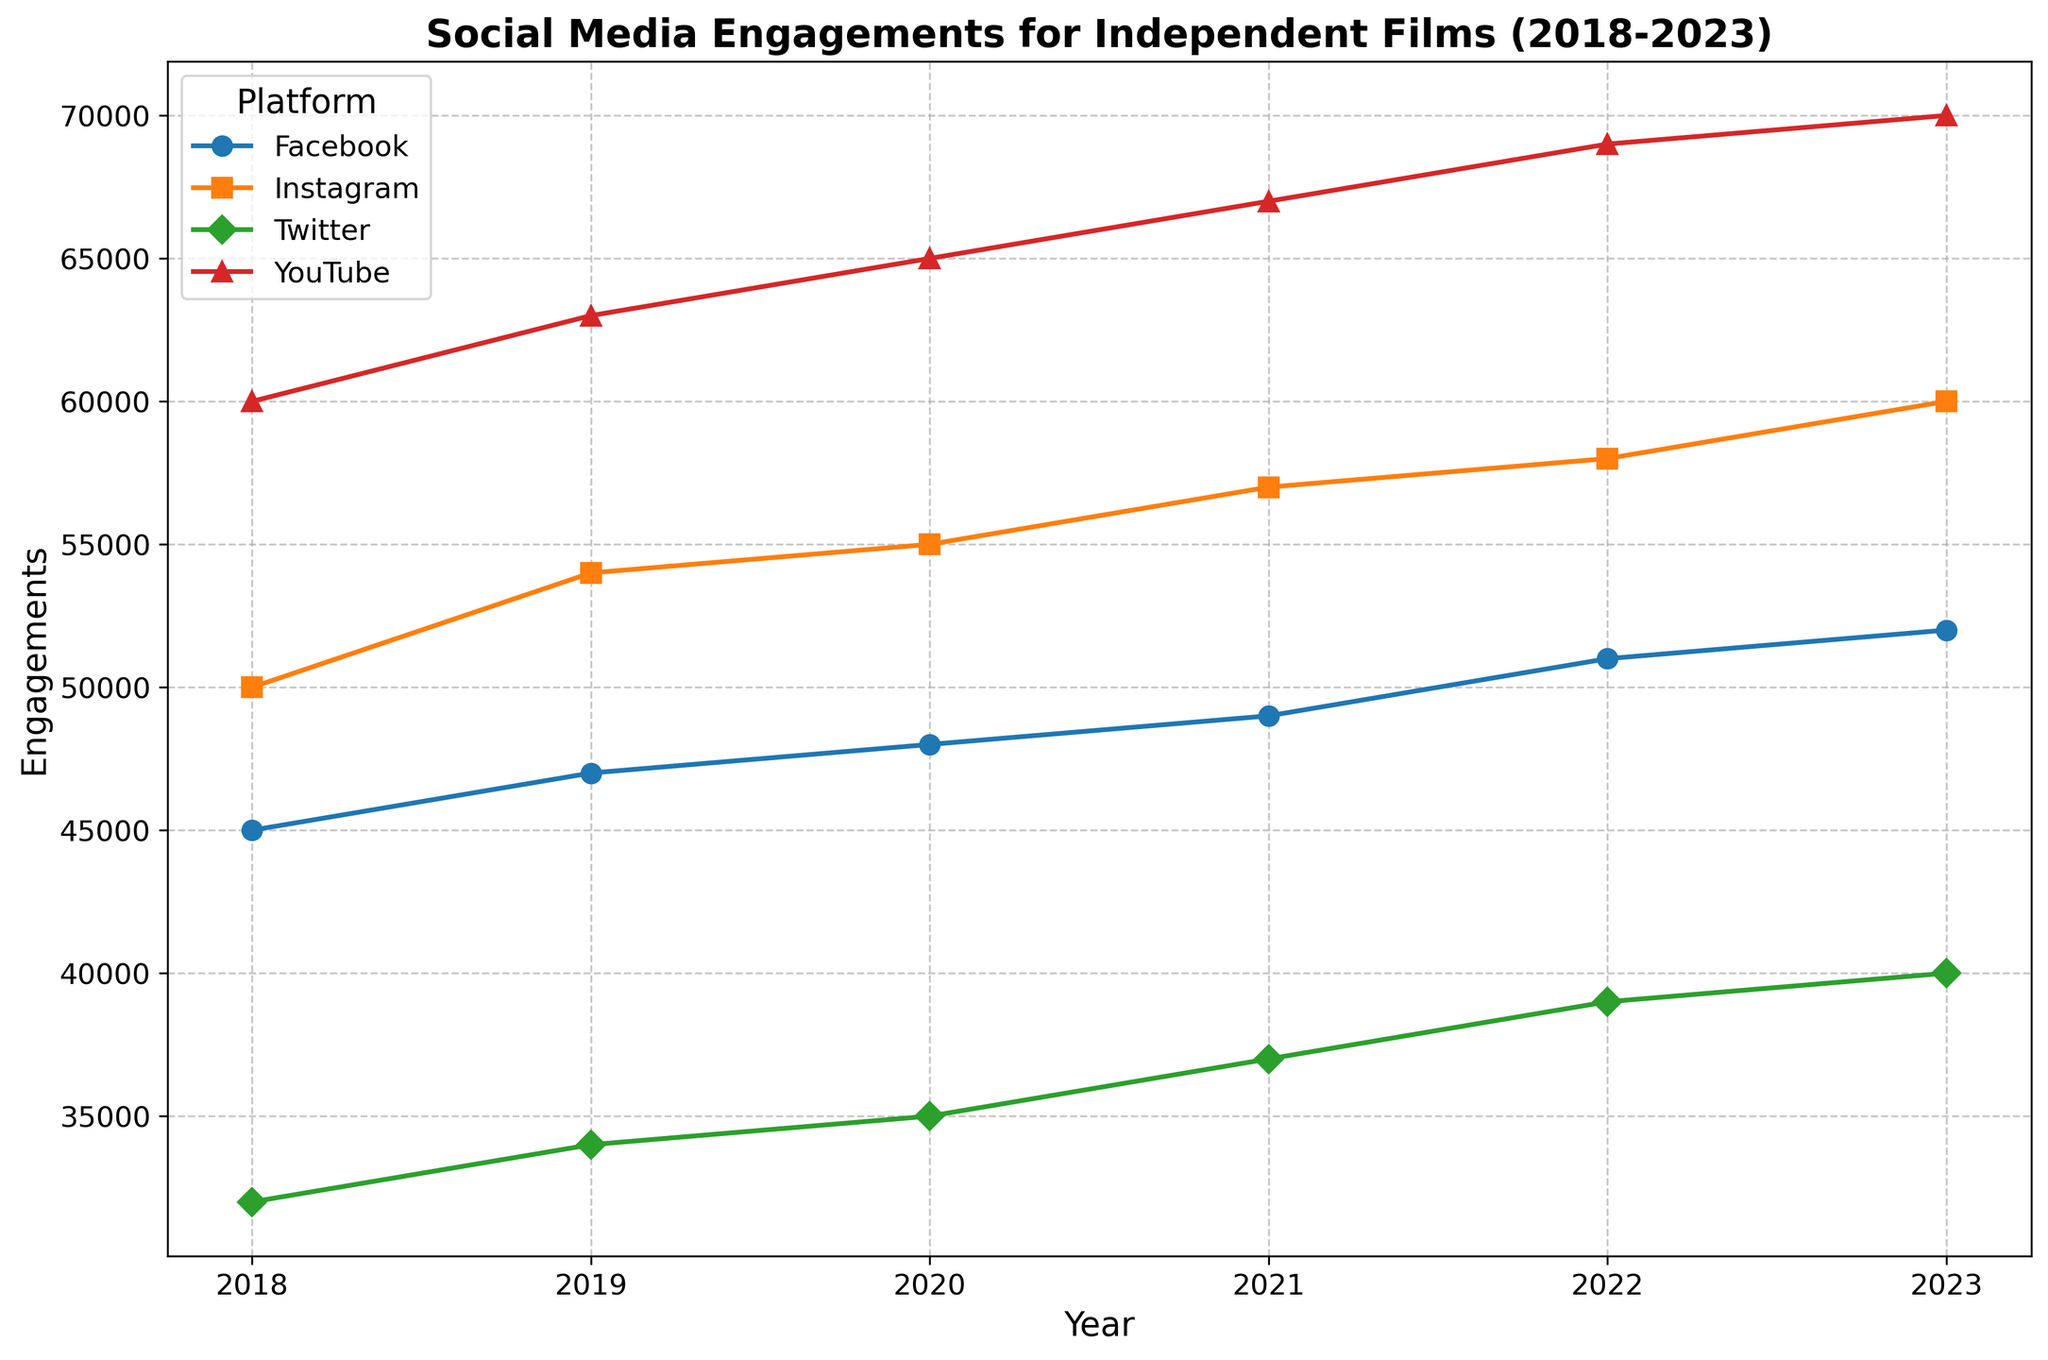How did Instagram engagements change from 2018 to 2023? Look at the Instagram line in the chart. Compare the engagement value in 2018 with the value in 2023. Engagements in 2018 were 50,000, and in 2023 they reached 60,000.
Answer: Increased by 10,000 Which platform saw the highest engagement in 2023? Refer to the final year (2023) on the x-axis and identify the platform with the highest engagement value. YouTube has the highest engagement with 70,000.
Answer: YouTube Did any platform's engagements decrease from 2018 to 2023? Observe the trend of each platform from 2018 to 2023. None of the platforms show a decreasing trend over the years.
Answer: No Between 2019 and 2020, which platform had the largest increase in engagements? Compare the engagement values for each platform between 2019 and 2020. Calculate the differences: 
- Facebook: 48,000 - 47,000 = 1,000
- Twitter: 35,000 - 34,000 = 1,000
- Instagram: 55,000 - 54,000 = 1,000
- YouTube: 65,000 - 63,000 = 2,000
YouTube had the largest increase with 2,000.
Answer: YouTube What is the average engagement for Twitter over the 5 years? Sum up all the engagements for Twitter and divide by the number of years. (32,000 + 34,000 + 35,000 + 37,000 + 39,000 + 40,000) / 6 = (217,000 / 6) ≈ 36,167
Answer: 36,167 Which platform had the steepest increase in engagements between any two consecutive years? Identify the year-on-year differences for each platform: 
- Facebook: 
    - 2018-2019: 47,000 - 45,000 = 2,000
    - 2019-2020: 48,000 - 47,000 = 1,000
    - 2020-2021: 49,000 - 48,000 = 1,000
    - 2021-2022: 51,000 - 49,000 = 2,000
    - 2022-2023: 52,000 - 51,000 = 1,000
- Twitter: 
    - 2018-2019: 34,000 - 32,000 = 2,000
    - 2019-2020: 35,000 - 34,000 = 1,000
    - 2020-2021: 37,000 - 35,000 = 2,000
    - 2021-2022: 39,000 - 37,000 = 2,000
    - 2022-2023: 40,000 - 39,000 = 1,000
- Instagram: 
    - 2018-2019: 54,000 - 50,000 = 4,000
    - 2019-2020: 55,000 - 54,000 = 1,000
    - 2020-2021: 57,000 - 55,000 = 2,000
    - 2021-2022: 58,000 - 57,000 = 1,000
    - 2022-2023: 60,000 - 58,000 = 2,000
- YouTube: 
    - 2018-2019: 63,000 - 60,000 = 3,000
    - 2019-2020: 65,000 - 63,000 = 2,000
    - 2020-2021: 67,000 - 65,000 = 2,000
    - 2021-2022: 69,000 - 67,000 = 2,000
    - 2022-2023: 70,000 - 69,000 = 1,000
Instagram had the steepest increase of 4,000 between 2018 and 2019.
Answer: Instagram Which year had the least combined engagements across all platforms? Add up the engagements for all platforms for each year and compare:
- 2018: 45,000 + 32,000 + 50,000 + 60,000 = 187,000
- 2019: 47,000 + 34,000 + 54,000 + 63,000 = 198,000
- 2020: 48,000 + 35,000 + 55,000 + 65,000 = 203,000
- 2021: 49,000 + 37,000 + 57,000 + 67,000 = 210,000
- 2022: 51,000 + 39,000 + 58,000 + 69,000 = 217,000
- 2023: 52,000 + 40,000 + 60,000 + 70,000 = 222,000
2018 had the least combined engagements.
Answer: 2018 What is the trend of the Facebook engagements over the 5 years? Observe the Facebook line on the chart from 2018 to 2023. Facebook engagements have consistently increased.
Answer: Increasing Which year showed the highest engagement increase for YouTube compared to the previous year? Calculate the engagement increases for YouTube:
- 2018-2019: 63,000 - 60,000 = 3,000
- 2019-2020: 65,000 - 63,000 = 2,000
- 2020-2021: 67,000 - 65,000 = 2,000
- 2021-2022: 69,000 - 67,000 = 2,000
- 2022-2023: 70,000 - 69,000 = 1,000
The highest increase was 3,000 from 2018 to 2019.
Answer: 2018-2019 Comparing Facebook and Instagram, which platform had a greater engagement increase from 2018 to 2023? Calculate the engagement increase for each platform:
- Facebook: 52,000 - 45,000 = 7,000
- Instagram: 60,000 - 50,000 = 10,000
Instagram had a greater increase of 10,000.
Answer: Instagram 